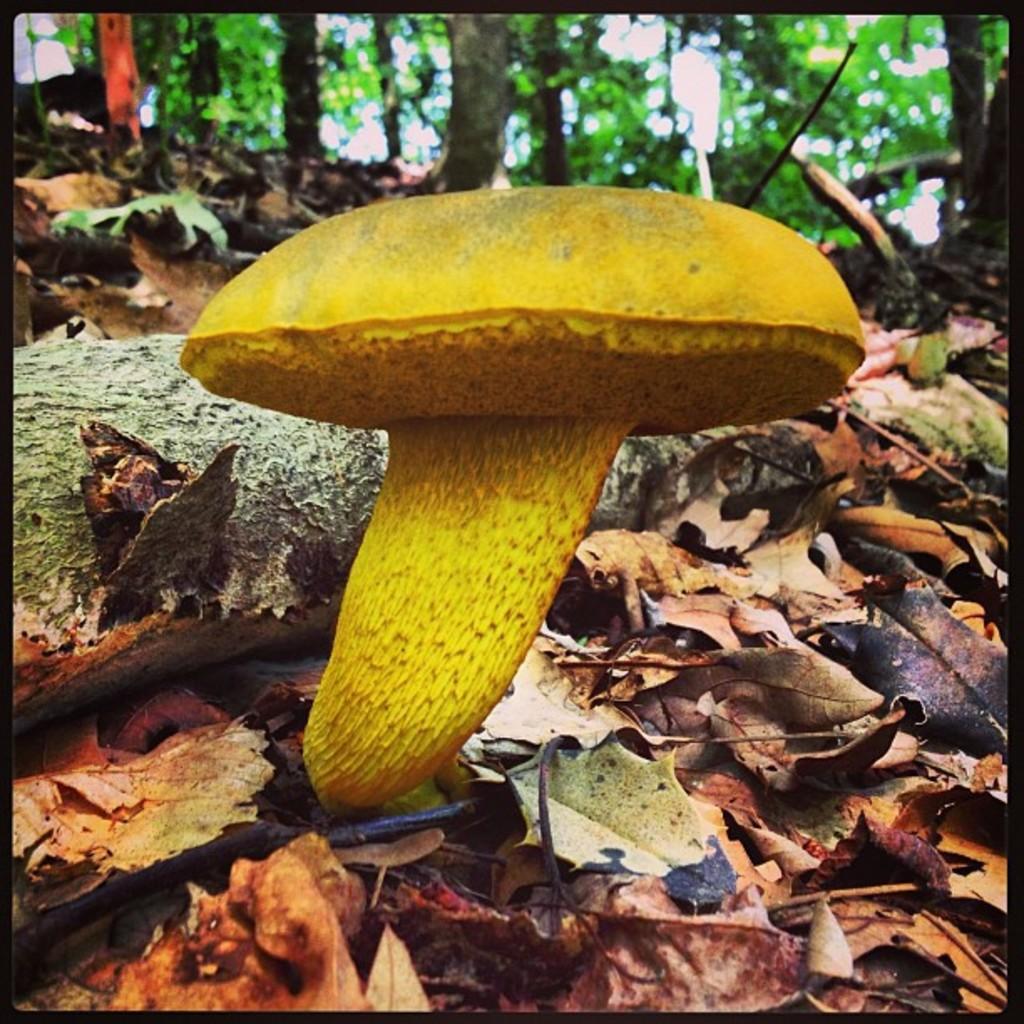In one or two sentences, can you explain what this image depicts? In this image we can see a mushroom and dried leaves. In the background there are trees. 